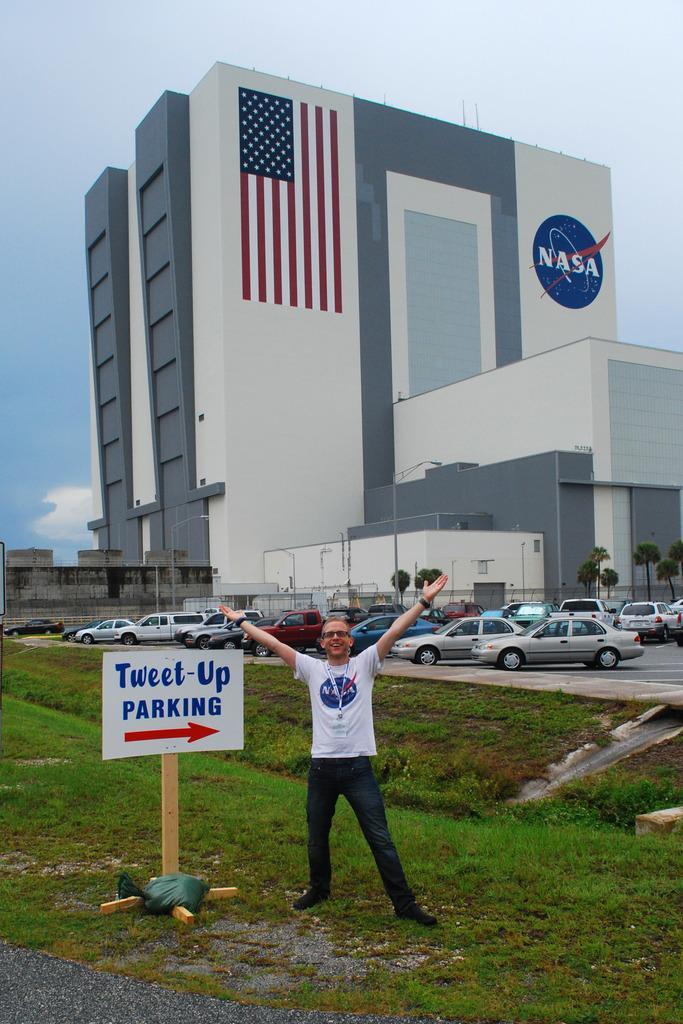Could you give a brief overview of what you see in this image? In this image, in the middle, we can see a man wearing white color shirt and standing on the grass. On the left side, we can see a hoarding and a wood pole. In the background, we can see some cars, building, trees and a flag which is attached to a building. At the top, we can see a sky, at the bottom, we can see a road and a grass. 